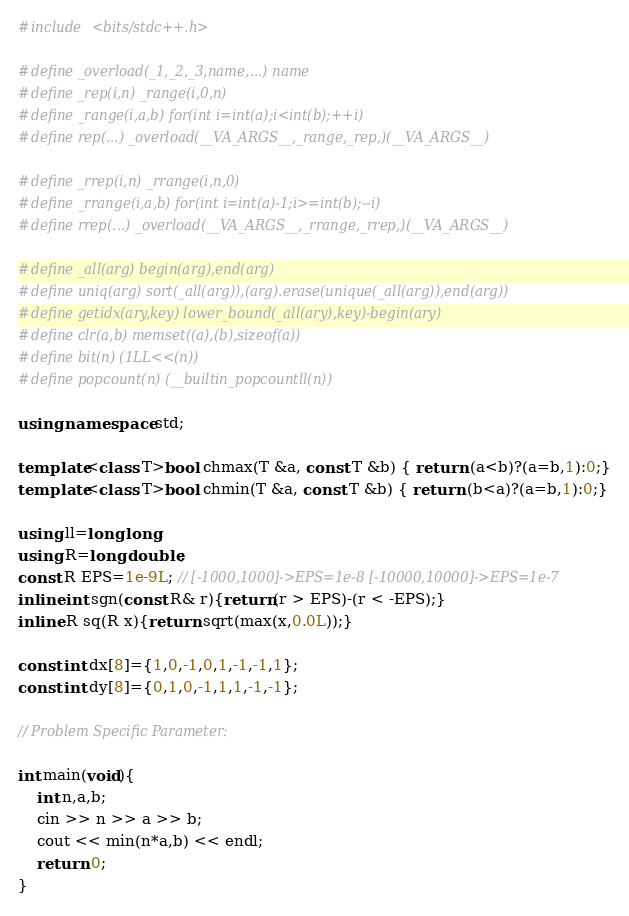<code> <loc_0><loc_0><loc_500><loc_500><_C++_>#include <bits/stdc++.h>

#define _overload(_1,_2,_3,name,...) name
#define _rep(i,n) _range(i,0,n)
#define _range(i,a,b) for(int i=int(a);i<int(b);++i)
#define rep(...) _overload(__VA_ARGS__,_range,_rep,)(__VA_ARGS__)

#define _rrep(i,n) _rrange(i,n,0)
#define _rrange(i,a,b) for(int i=int(a)-1;i>=int(b);--i)
#define rrep(...) _overload(__VA_ARGS__,_rrange,_rrep,)(__VA_ARGS__)

#define _all(arg) begin(arg),end(arg)
#define uniq(arg) sort(_all(arg)),(arg).erase(unique(_all(arg)),end(arg))
#define getidx(ary,key) lower_bound(_all(ary),key)-begin(ary)
#define clr(a,b) memset((a),(b),sizeof(a))
#define bit(n) (1LL<<(n))
#define popcount(n) (__builtin_popcountll(n))

using namespace std;

template<class T>bool chmax(T &a, const T &b) { return (a<b)?(a=b,1):0;}
template<class T>bool chmin(T &a, const T &b) { return (b<a)?(a=b,1):0;}

using ll=long long;
using R=long double;
const R EPS=1e-9L; // [-1000,1000]->EPS=1e-8 [-10000,10000]->EPS=1e-7
inline int sgn(const R& r){return(r > EPS)-(r < -EPS);}
inline R sq(R x){return sqrt(max(x,0.0L));}

const int dx[8]={1,0,-1,0,1,-1,-1,1};
const int dy[8]={0,1,0,-1,1,1,-1,-1};

// Problem Specific Parameter:

int main(void){
	int n,a,b;
	cin >> n >> a >> b;
	cout << min(n*a,b) << endl;
	return 0;
}</code> 